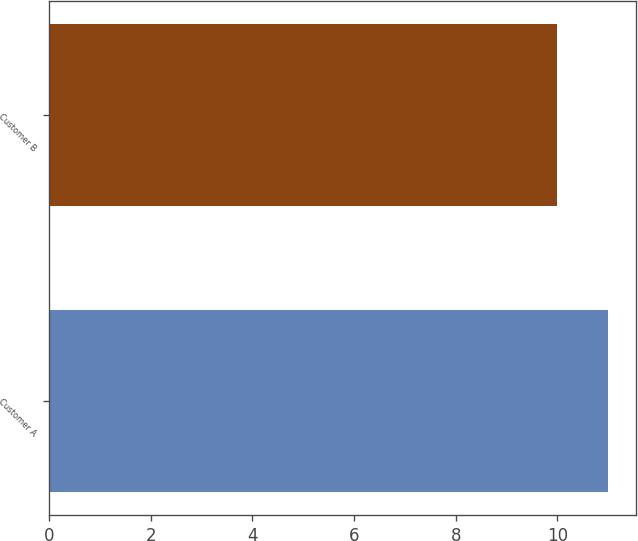<chart> <loc_0><loc_0><loc_500><loc_500><bar_chart><fcel>Customer A<fcel>Customer B<nl><fcel>11<fcel>10<nl></chart> 